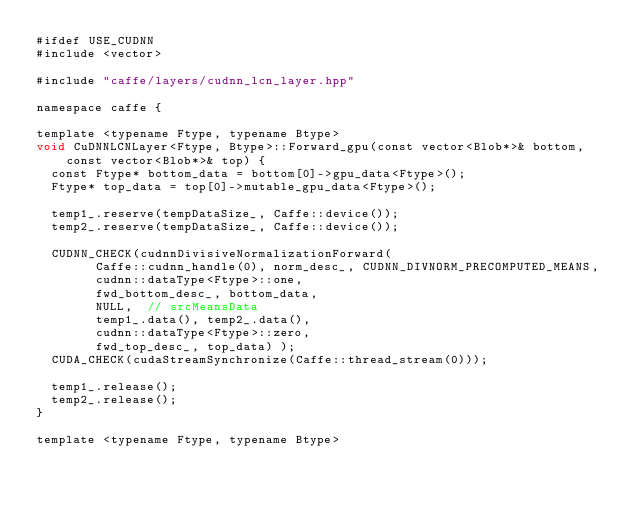Convert code to text. <code><loc_0><loc_0><loc_500><loc_500><_Cuda_>#ifdef USE_CUDNN
#include <vector>

#include "caffe/layers/cudnn_lcn_layer.hpp"

namespace caffe {

template <typename Ftype, typename Btype>
void CuDNNLCNLayer<Ftype, Btype>::Forward_gpu(const vector<Blob*>& bottom,
    const vector<Blob*>& top) {
  const Ftype* bottom_data = bottom[0]->gpu_data<Ftype>();
  Ftype* top_data = top[0]->mutable_gpu_data<Ftype>();

  temp1_.reserve(tempDataSize_, Caffe::device());
  temp2_.reserve(tempDataSize_, Caffe::device());

  CUDNN_CHECK(cudnnDivisiveNormalizationForward(
        Caffe::cudnn_handle(0), norm_desc_, CUDNN_DIVNORM_PRECOMPUTED_MEANS,
        cudnn::dataType<Ftype>::one,
        fwd_bottom_desc_, bottom_data,
        NULL,  // srcMeansData
        temp1_.data(), temp2_.data(),
        cudnn::dataType<Ftype>::zero,
        fwd_top_desc_, top_data) );
  CUDA_CHECK(cudaStreamSynchronize(Caffe::thread_stream(0)));

  temp1_.release();
  temp2_.release();
}

template <typename Ftype, typename Btype></code> 